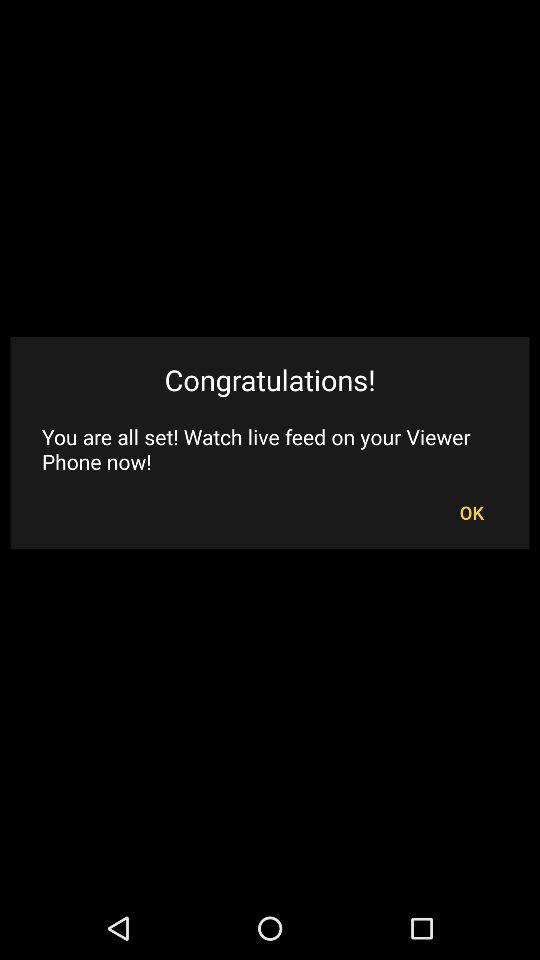What is the application name? The application name is "Alfred". 